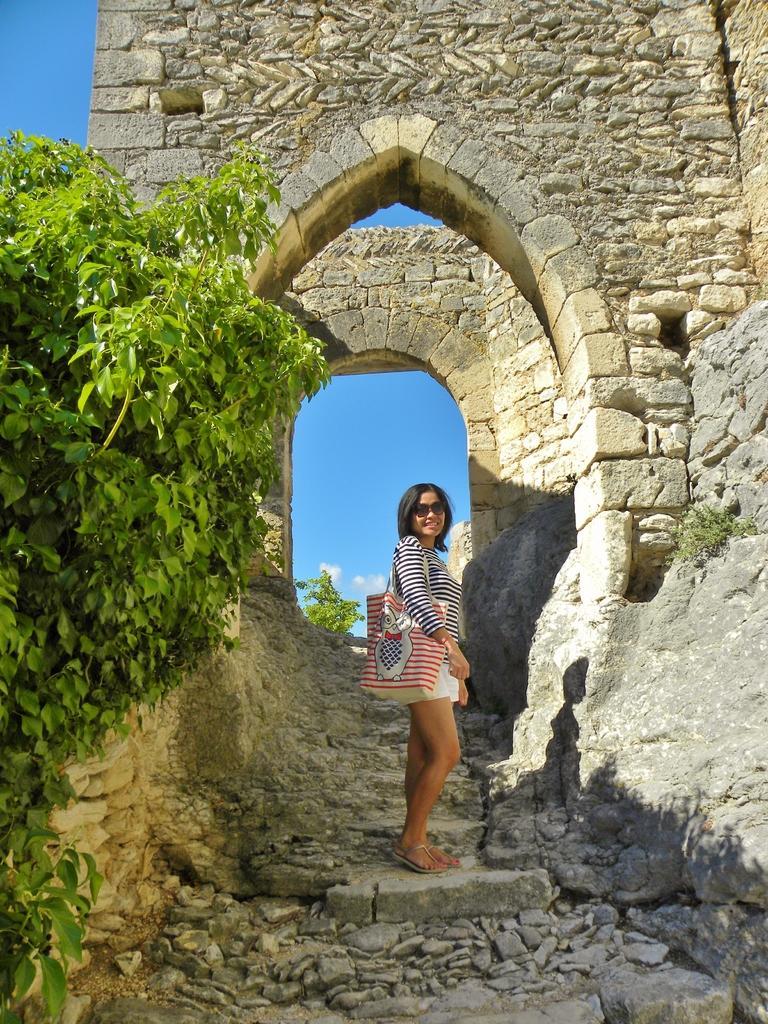In one or two sentences, can you explain what this image depicts? In this image there is a person smiling and standing on the stair case, and in the background there are arches of a building, plants, sky. 